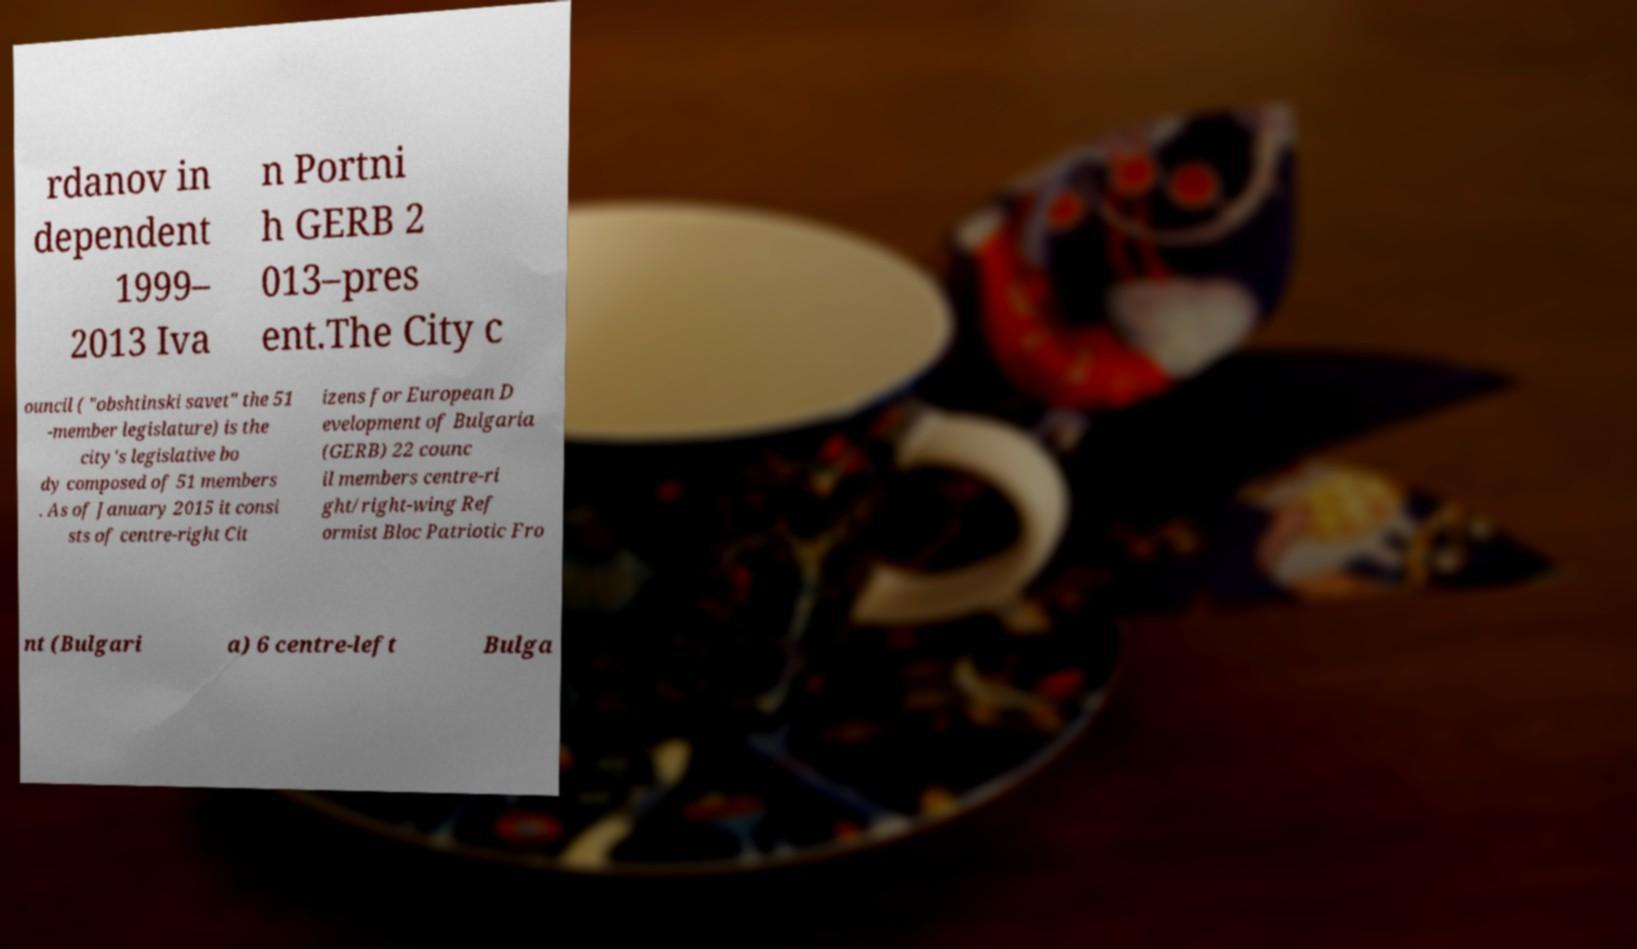Can you accurately transcribe the text from the provided image for me? rdanov in dependent 1999– 2013 Iva n Portni h GERB 2 013–pres ent.The City c ouncil ( "obshtinski savet" the 51 -member legislature) is the city's legislative bo dy composed of 51 members . As of January 2015 it consi sts of centre-right Cit izens for European D evelopment of Bulgaria (GERB) 22 counc il members centre-ri ght/right-wing Ref ormist Bloc Patriotic Fro nt (Bulgari a) 6 centre-left Bulga 